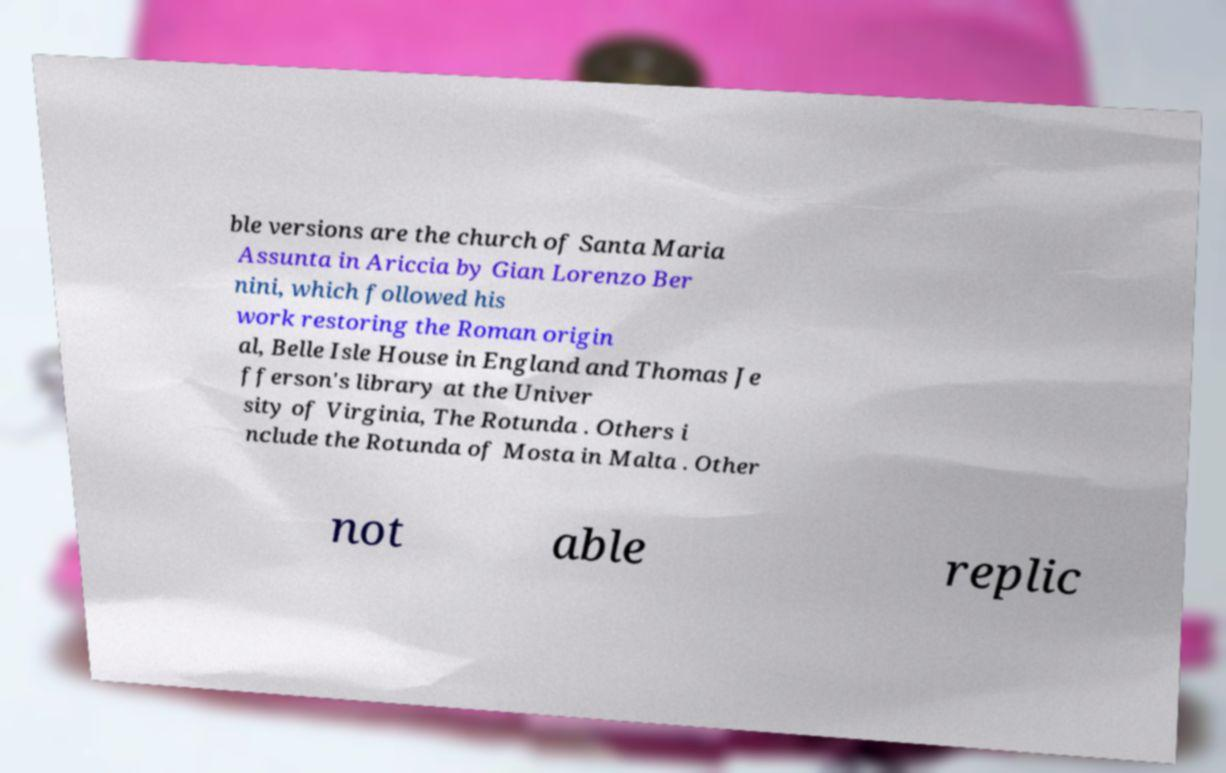Could you assist in decoding the text presented in this image and type it out clearly? ble versions are the church of Santa Maria Assunta in Ariccia by Gian Lorenzo Ber nini, which followed his work restoring the Roman origin al, Belle Isle House in England and Thomas Je fferson's library at the Univer sity of Virginia, The Rotunda . Others i nclude the Rotunda of Mosta in Malta . Other not able replic 